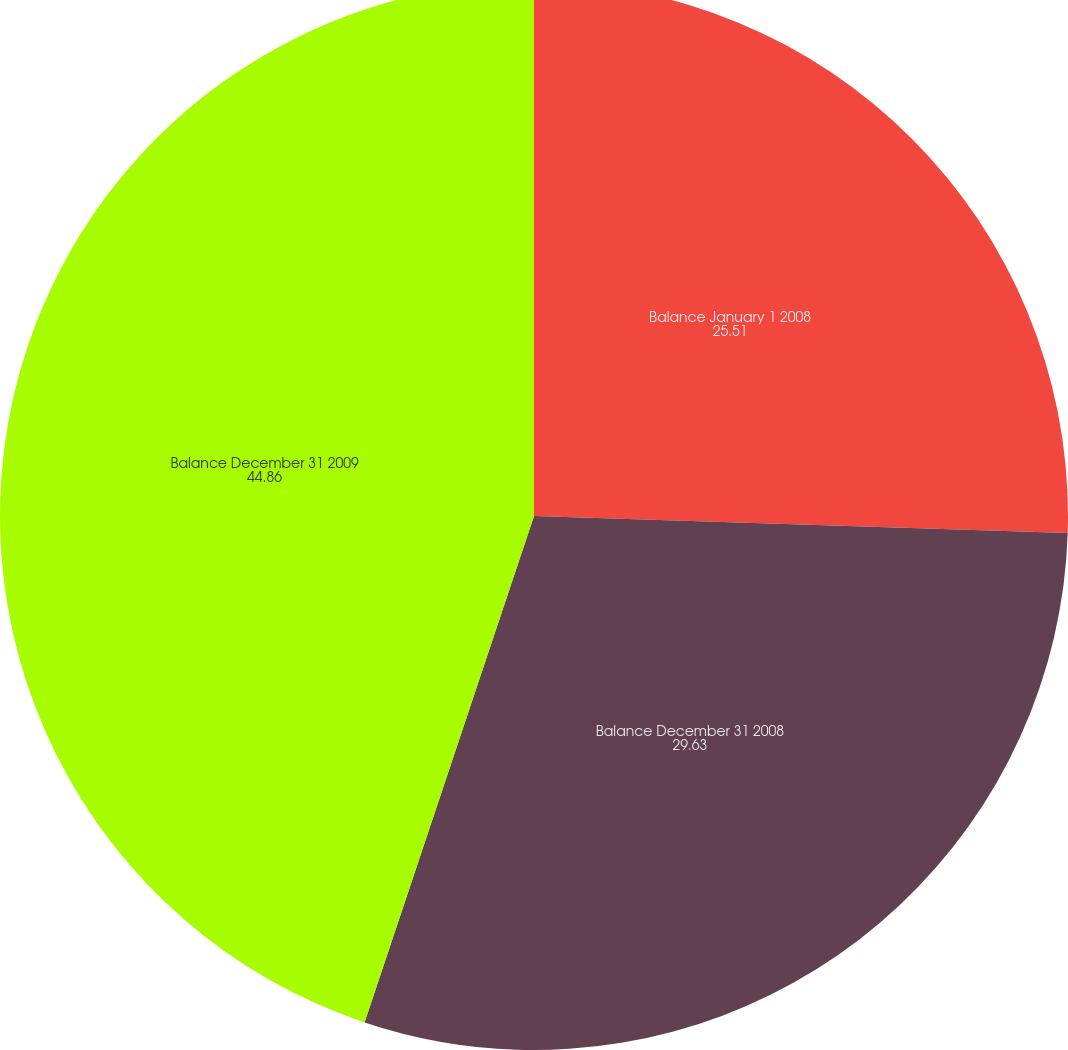Convert chart to OTSL. <chart><loc_0><loc_0><loc_500><loc_500><pie_chart><fcel>Balance January 1 2008<fcel>Balance December 31 2008<fcel>Balance December 31 2009<nl><fcel>25.51%<fcel>29.63%<fcel>44.86%<nl></chart> 